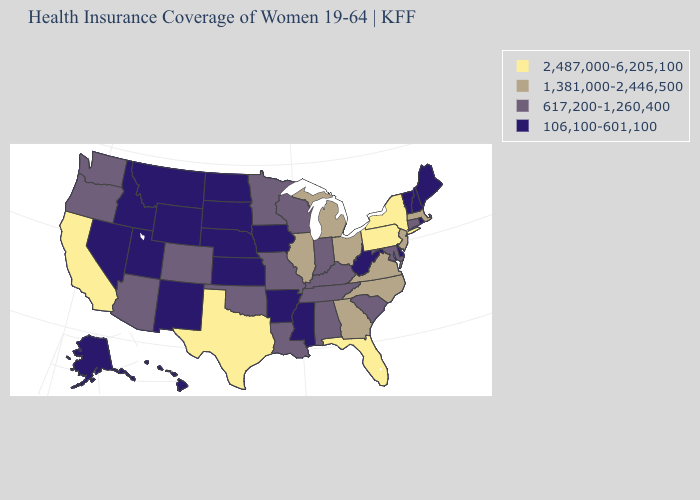What is the value of Delaware?
Answer briefly. 106,100-601,100. What is the value of Michigan?
Give a very brief answer. 1,381,000-2,446,500. What is the value of Tennessee?
Give a very brief answer. 617,200-1,260,400. What is the value of Georgia?
Short answer required. 1,381,000-2,446,500. Does Nebraska have the lowest value in the USA?
Keep it brief. Yes. Does the map have missing data?
Write a very short answer. No. Does Maine have the highest value in the USA?
Keep it brief. No. Name the states that have a value in the range 617,200-1,260,400?
Short answer required. Alabama, Arizona, Colorado, Connecticut, Indiana, Kentucky, Louisiana, Maryland, Minnesota, Missouri, Oklahoma, Oregon, South Carolina, Tennessee, Washington, Wisconsin. Does Iowa have the lowest value in the USA?
Write a very short answer. Yes. What is the value of New Jersey?
Keep it brief. 1,381,000-2,446,500. Does the map have missing data?
Be succinct. No. What is the value of South Dakota?
Answer briefly. 106,100-601,100. What is the value of Oklahoma?
Short answer required. 617,200-1,260,400. What is the value of Nevada?
Give a very brief answer. 106,100-601,100. How many symbols are there in the legend?
Concise answer only. 4. 